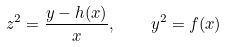<formula> <loc_0><loc_0><loc_500><loc_500>z ^ { 2 } = \frac { y - h ( x ) } { x } , \quad y ^ { 2 } = f ( x )</formula> 